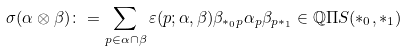Convert formula to latex. <formula><loc_0><loc_0><loc_500><loc_500>\sigma ( \alpha \otimes \beta ) \colon = \sum _ { p \in \alpha \cap \beta } \varepsilon ( p ; \alpha , \beta ) \beta _ { * _ { 0 } p } \alpha _ { p } \beta _ { p * _ { 1 } } \in \mathbb { Q } \Pi S ( * _ { 0 } , * _ { 1 } )</formula> 